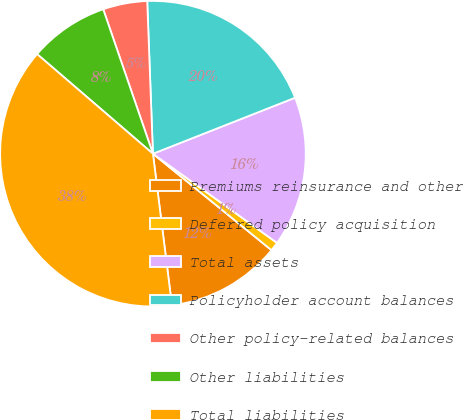Convert chart. <chart><loc_0><loc_0><loc_500><loc_500><pie_chart><fcel>Premiums reinsurance and other<fcel>Deferred policy acquisition<fcel>Total assets<fcel>Policyholder account balances<fcel>Other policy-related balances<fcel>Other liabilities<fcel>Total liabilities<nl><fcel>12.15%<fcel>0.95%<fcel>15.89%<fcel>19.62%<fcel>4.68%<fcel>8.42%<fcel>38.29%<nl></chart> 